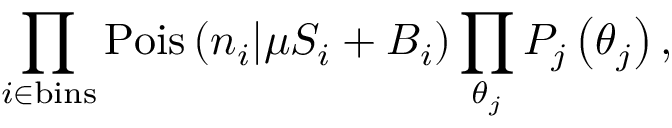<formula> <loc_0><loc_0><loc_500><loc_500>\prod _ { i \in b i n s } P o i s \left ( n _ { i } | \mu S _ { i } + B _ { i } \right ) \prod _ { \theta _ { j } } P _ { j } \left ( \theta _ { j } \right ) ,</formula> 